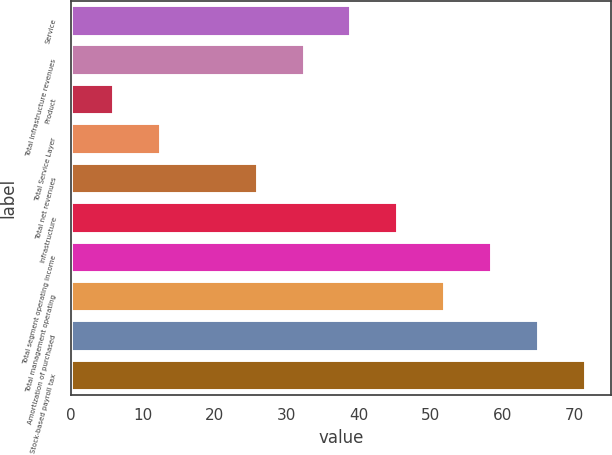Convert chart to OTSL. <chart><loc_0><loc_0><loc_500><loc_500><bar_chart><fcel>Service<fcel>Total Infrastructure revenues<fcel>Product<fcel>Total Service Layer<fcel>Total net revenues<fcel>Infrastructure<fcel>Total segment operating income<fcel>Total management operating<fcel>Amortization of purchased<fcel>Stock-based payroll tax<nl><fcel>39<fcel>32.5<fcel>6<fcel>12.5<fcel>26<fcel>45.5<fcel>58.5<fcel>52<fcel>65<fcel>71.5<nl></chart> 